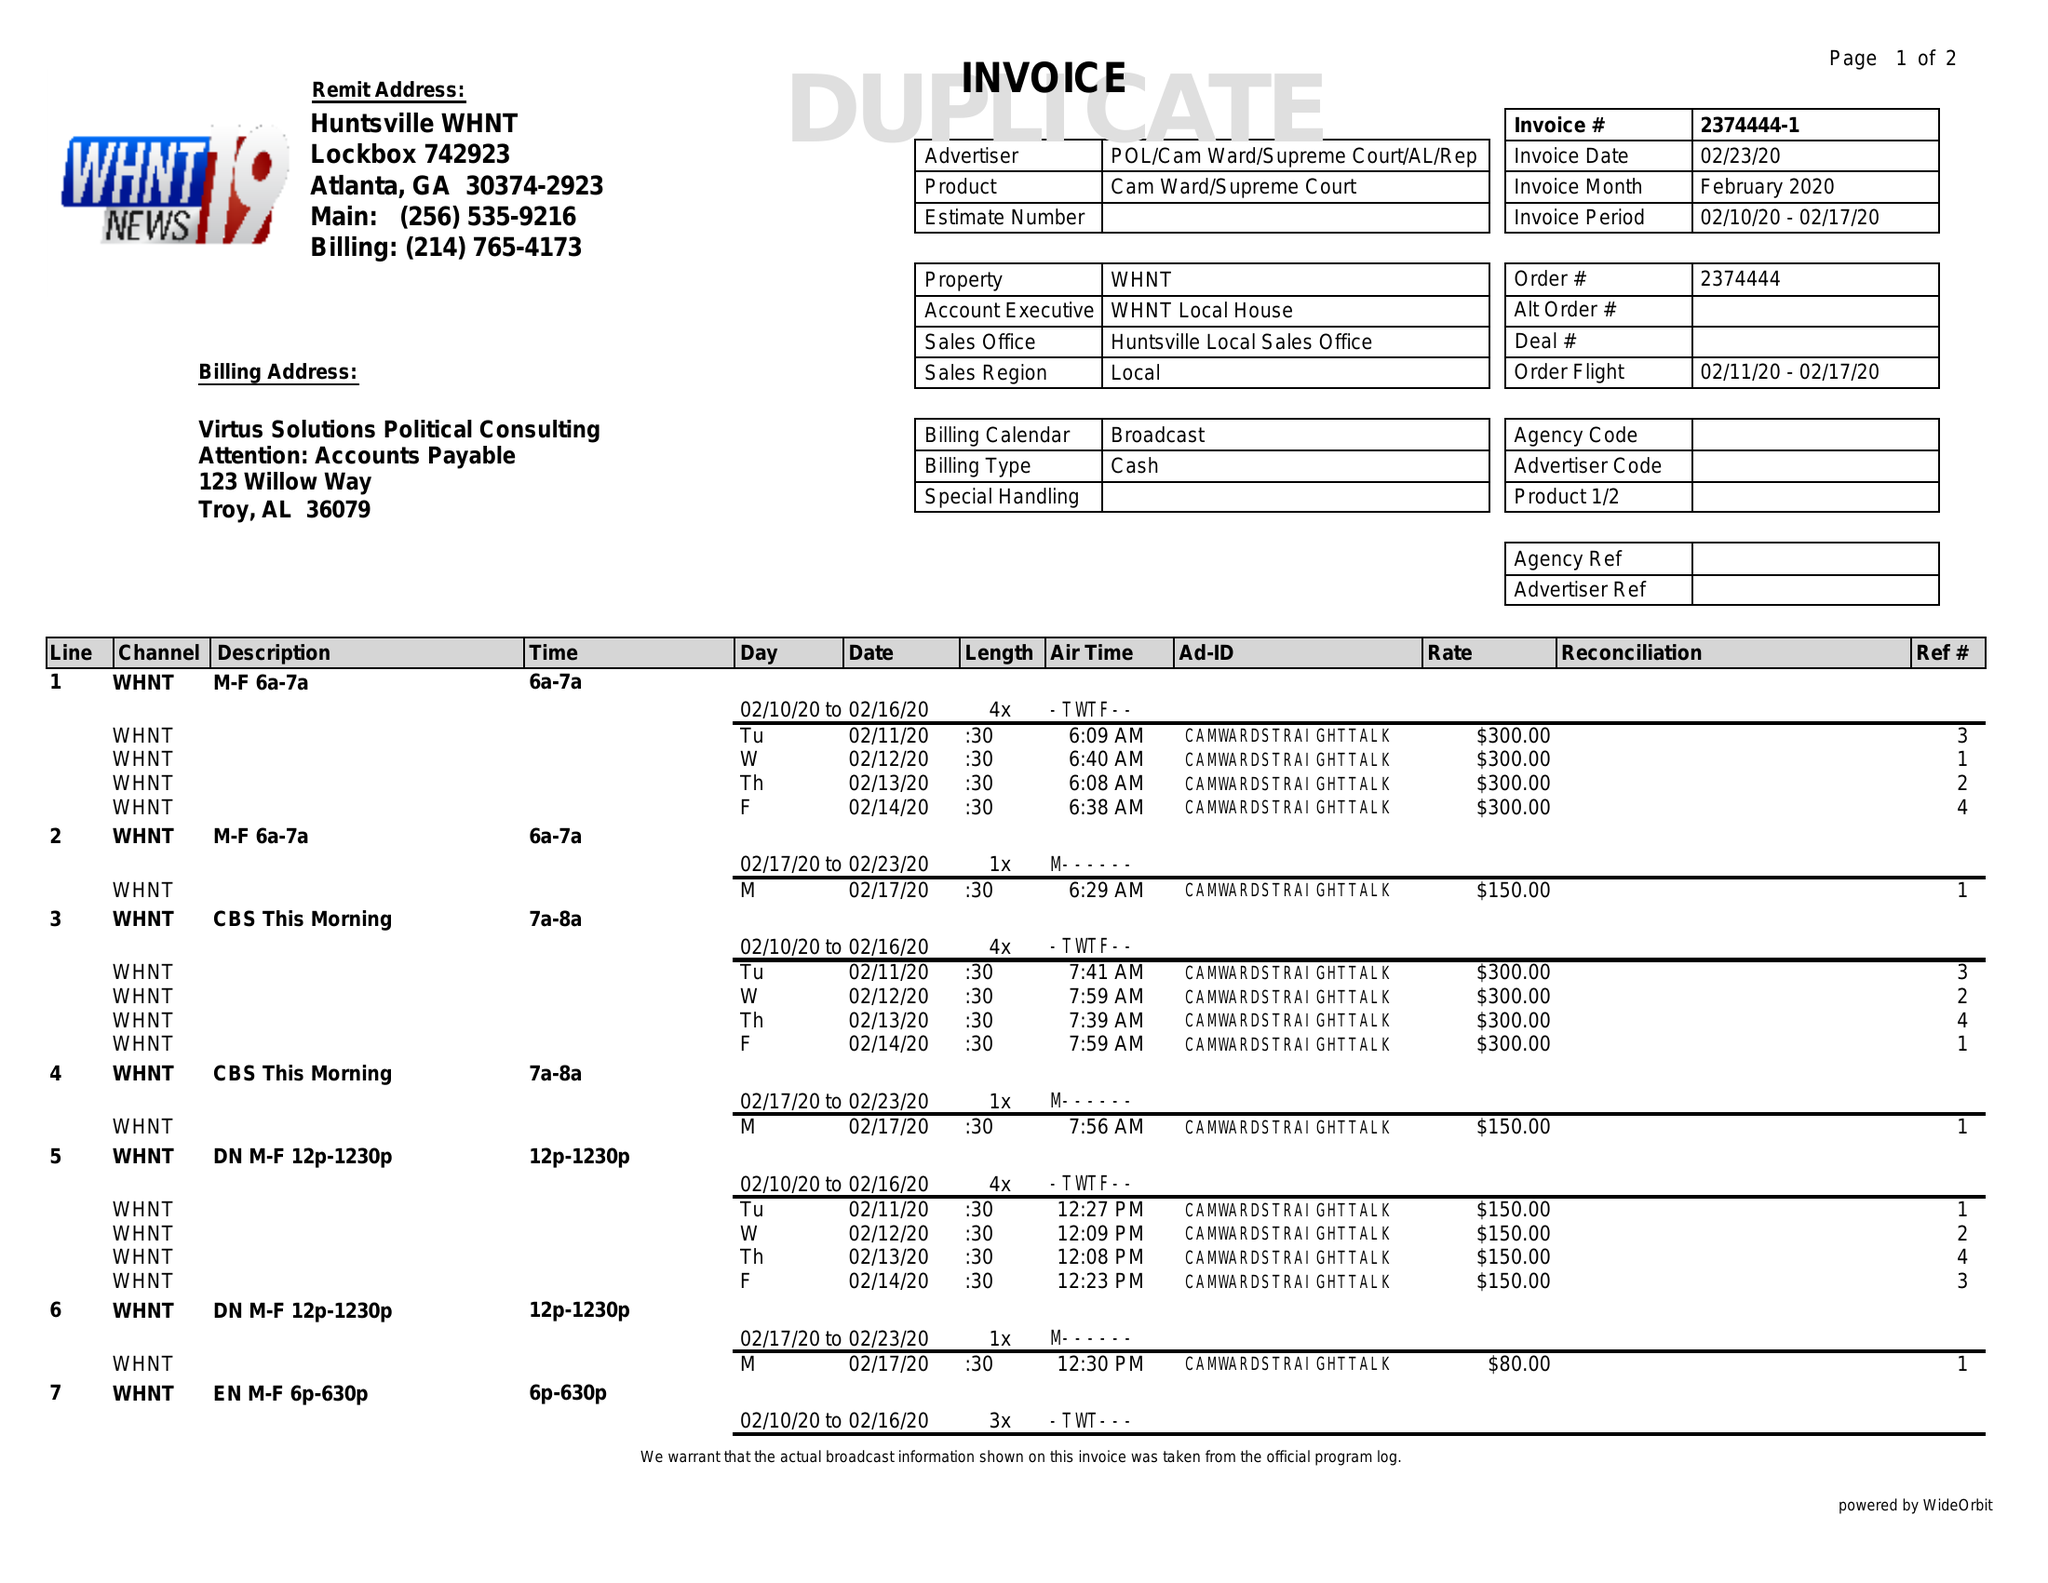What is the value for the flight_to?
Answer the question using a single word or phrase. 02/17/20 